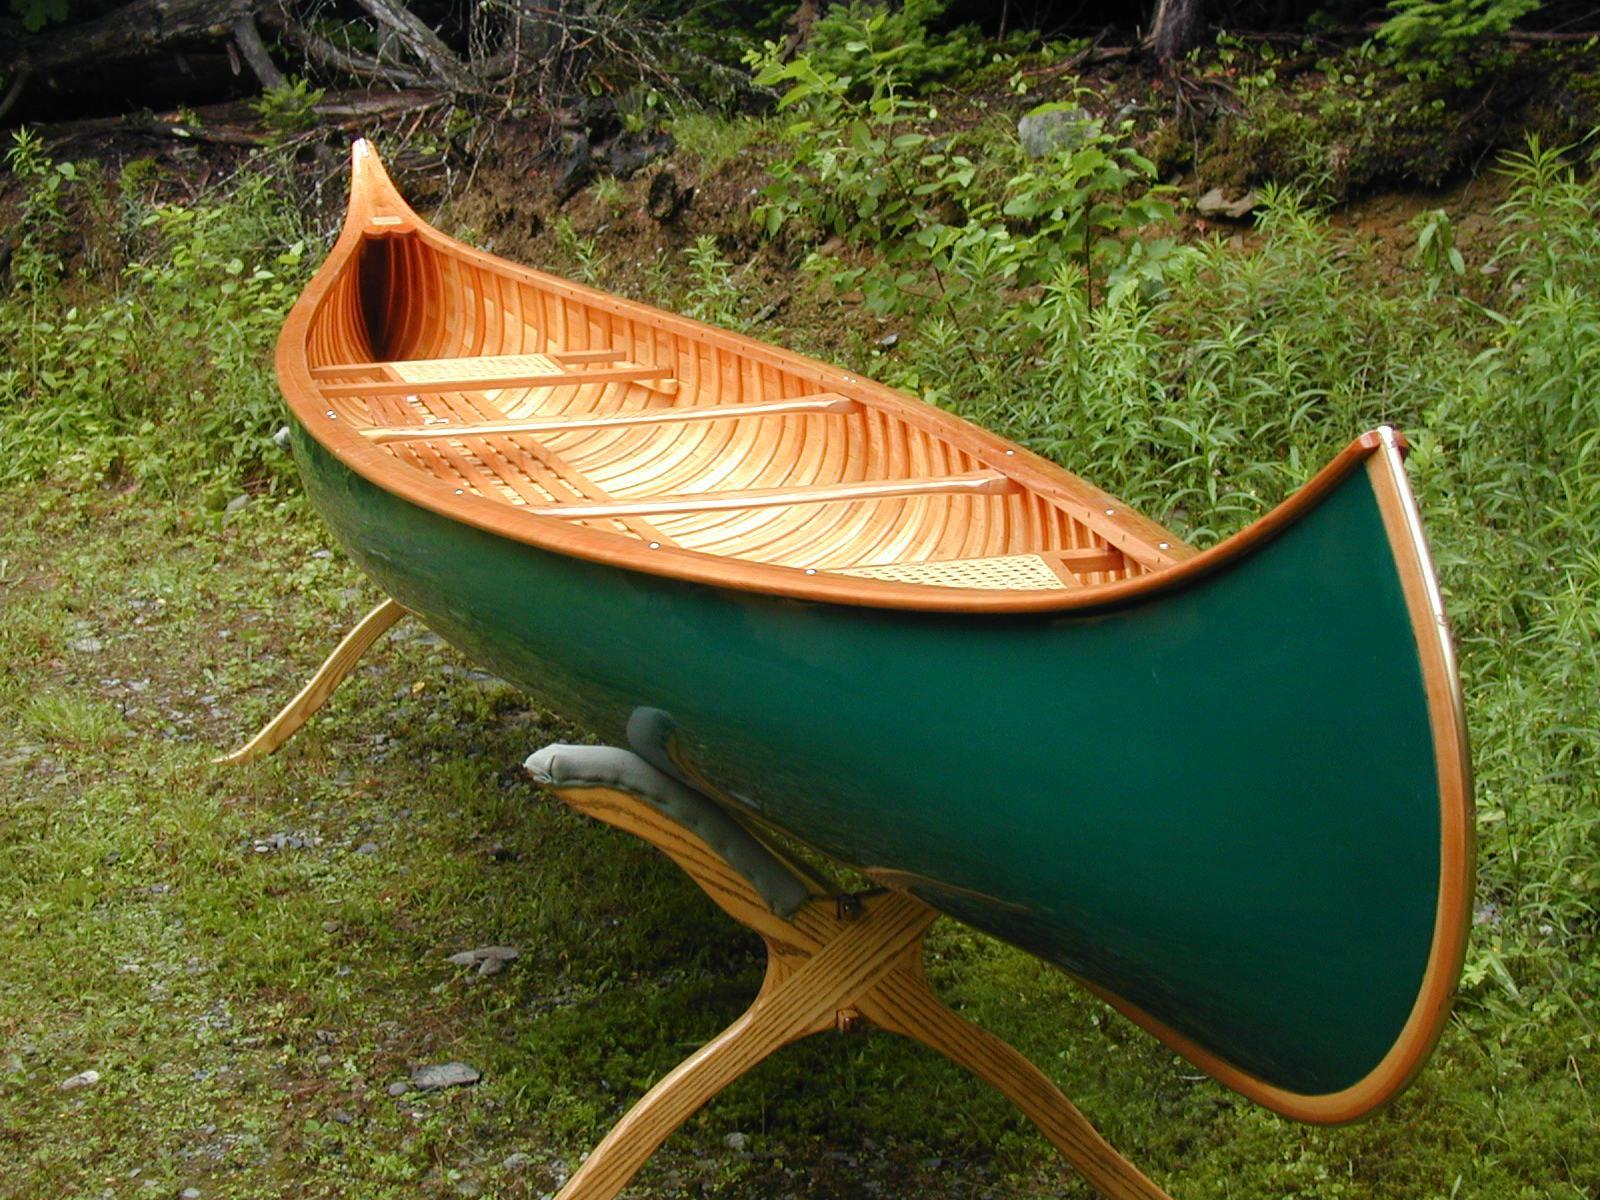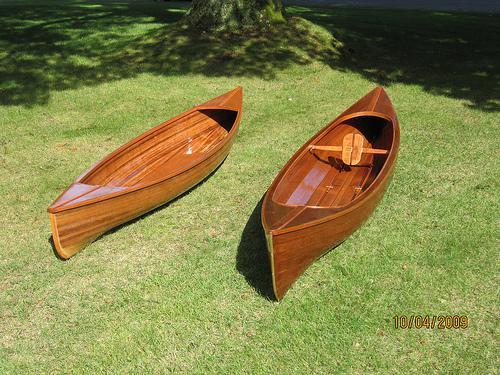The first image is the image on the left, the second image is the image on the right. Considering the images on both sides, is "One canoe is near water." valid? Answer yes or no. No. The first image is the image on the left, the second image is the image on the right. Analyze the images presented: Is the assertion "Two boats sit on the land in the image on the right." valid? Answer yes or no. Yes. 